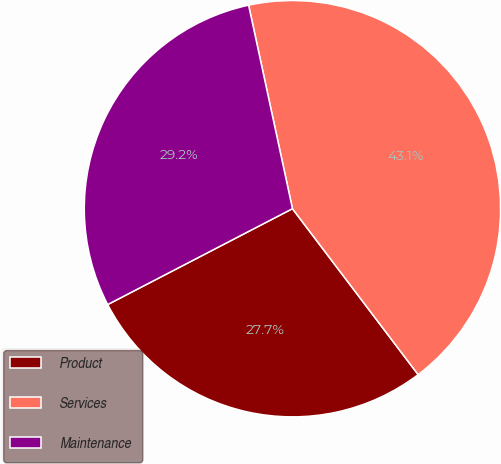<chart> <loc_0><loc_0><loc_500><loc_500><pie_chart><fcel>Product<fcel>Services<fcel>Maintenance<nl><fcel>27.7%<fcel>43.06%<fcel>29.24%<nl></chart> 